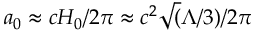<formula> <loc_0><loc_0><loc_500><loc_500>a _ { 0 } \approx { c H _ { 0 } } / { 2 \pi } \approx c ^ { 2 } \sqrt { ( } \Lambda / 3 ) / { 2 \pi }</formula> 